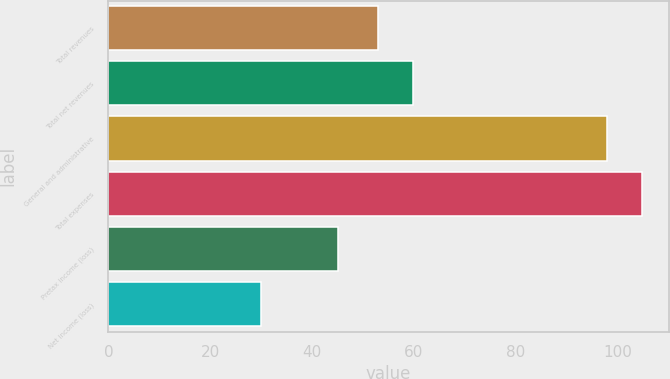Convert chart to OTSL. <chart><loc_0><loc_0><loc_500><loc_500><bar_chart><fcel>Total revenues<fcel>Total net revenues<fcel>General and administrative<fcel>Total expenses<fcel>Pretax income (loss)<fcel>Net income (loss)<nl><fcel>53<fcel>59.8<fcel>98<fcel>104.8<fcel>45<fcel>30<nl></chart> 